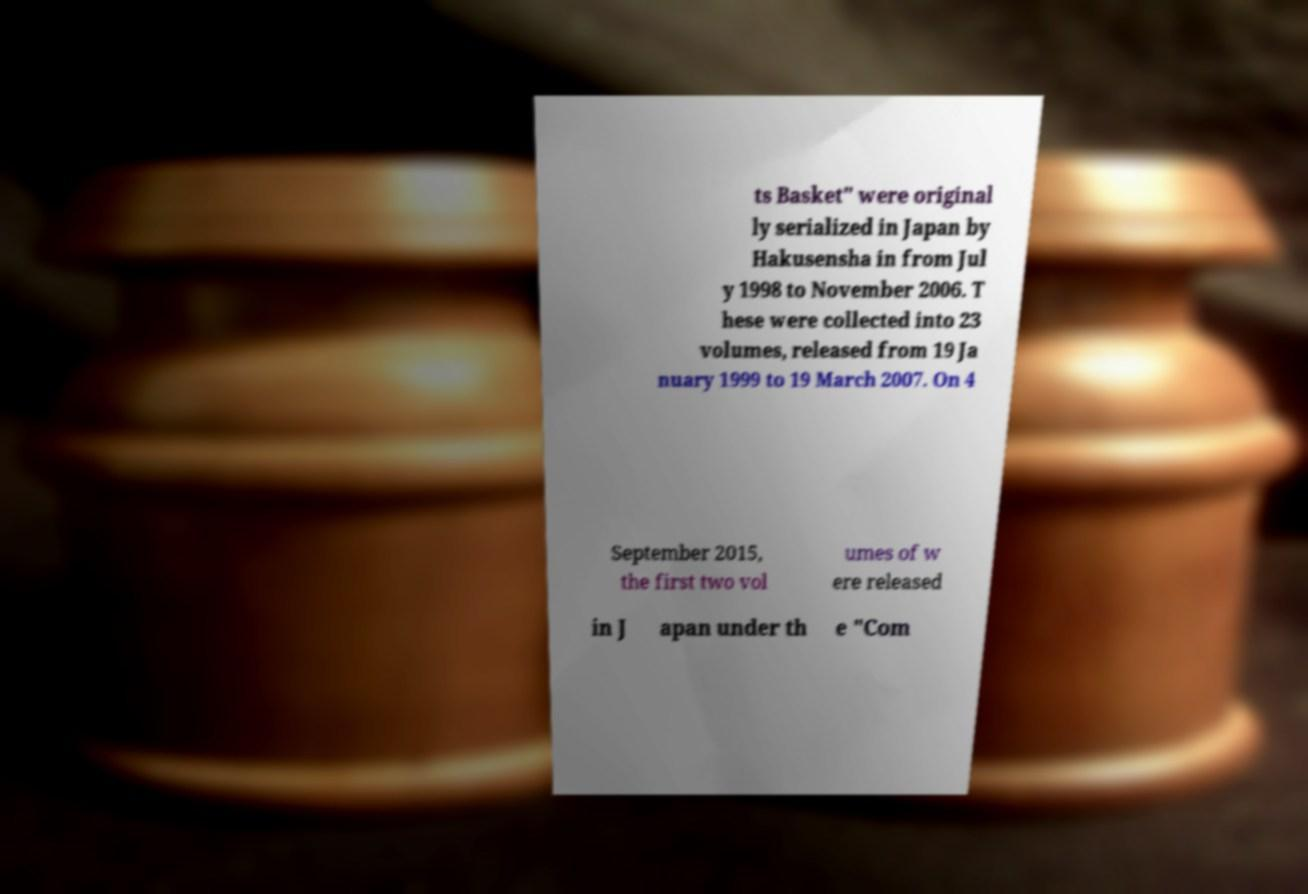Can you read and provide the text displayed in the image?This photo seems to have some interesting text. Can you extract and type it out for me? ts Basket" were original ly serialized in Japan by Hakusensha in from Jul y 1998 to November 2006. T hese were collected into 23 volumes, released from 19 Ja nuary 1999 to 19 March 2007. On 4 September 2015, the first two vol umes of w ere released in J apan under th e "Com 